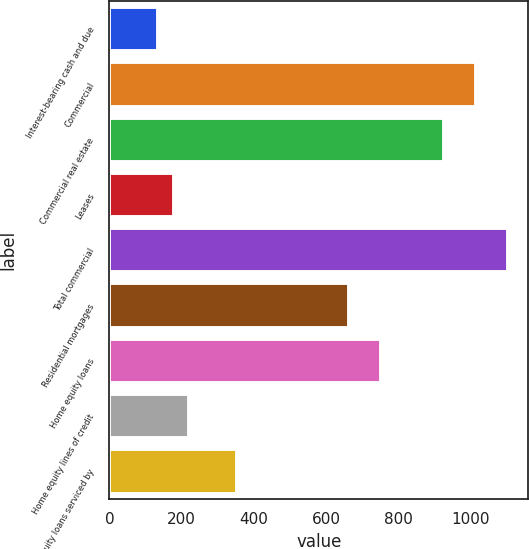Convert chart. <chart><loc_0><loc_0><loc_500><loc_500><bar_chart><fcel>Interest-bearing cash and due<fcel>Commercial<fcel>Commercial real estate<fcel>Leases<fcel>Total commercial<fcel>Residential mortgages<fcel>Home equity loans<fcel>Home equity lines of credit<fcel>Home equity loans serviced by<nl><fcel>133.3<fcel>1015.3<fcel>927.1<fcel>177.4<fcel>1103.5<fcel>662.5<fcel>750.7<fcel>221.5<fcel>353.8<nl></chart> 